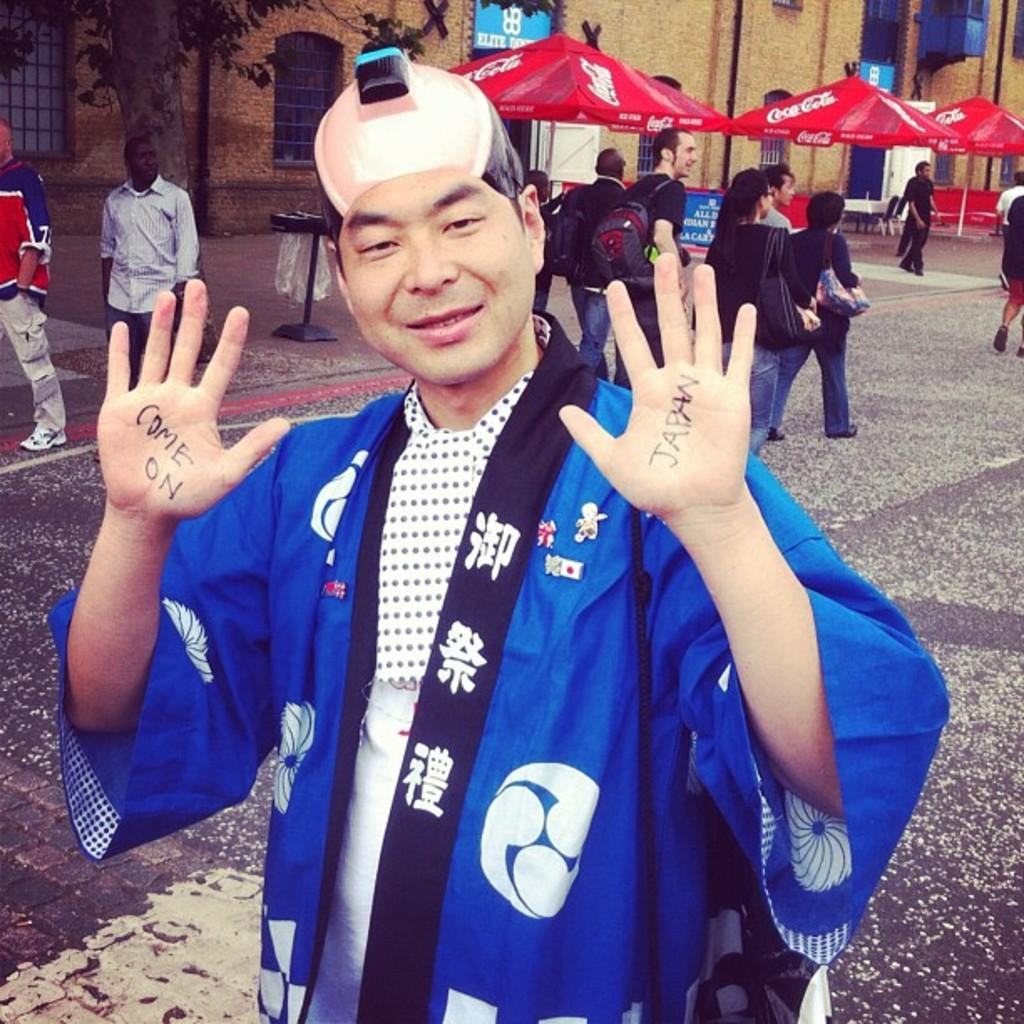What is the person in the image wearing? The person in the image is wearing clothes. Where can a group of people be found in the image? There is a group of people in the top right of the image. What are the people in the group doing? The group of people is walking beside umbrellas. What structure is visible at the top of the image? There is a building at the top of the image. What type of honey is being used to twist the goldfish in the image? There is no honey, twist, or goldfish present in the image. 